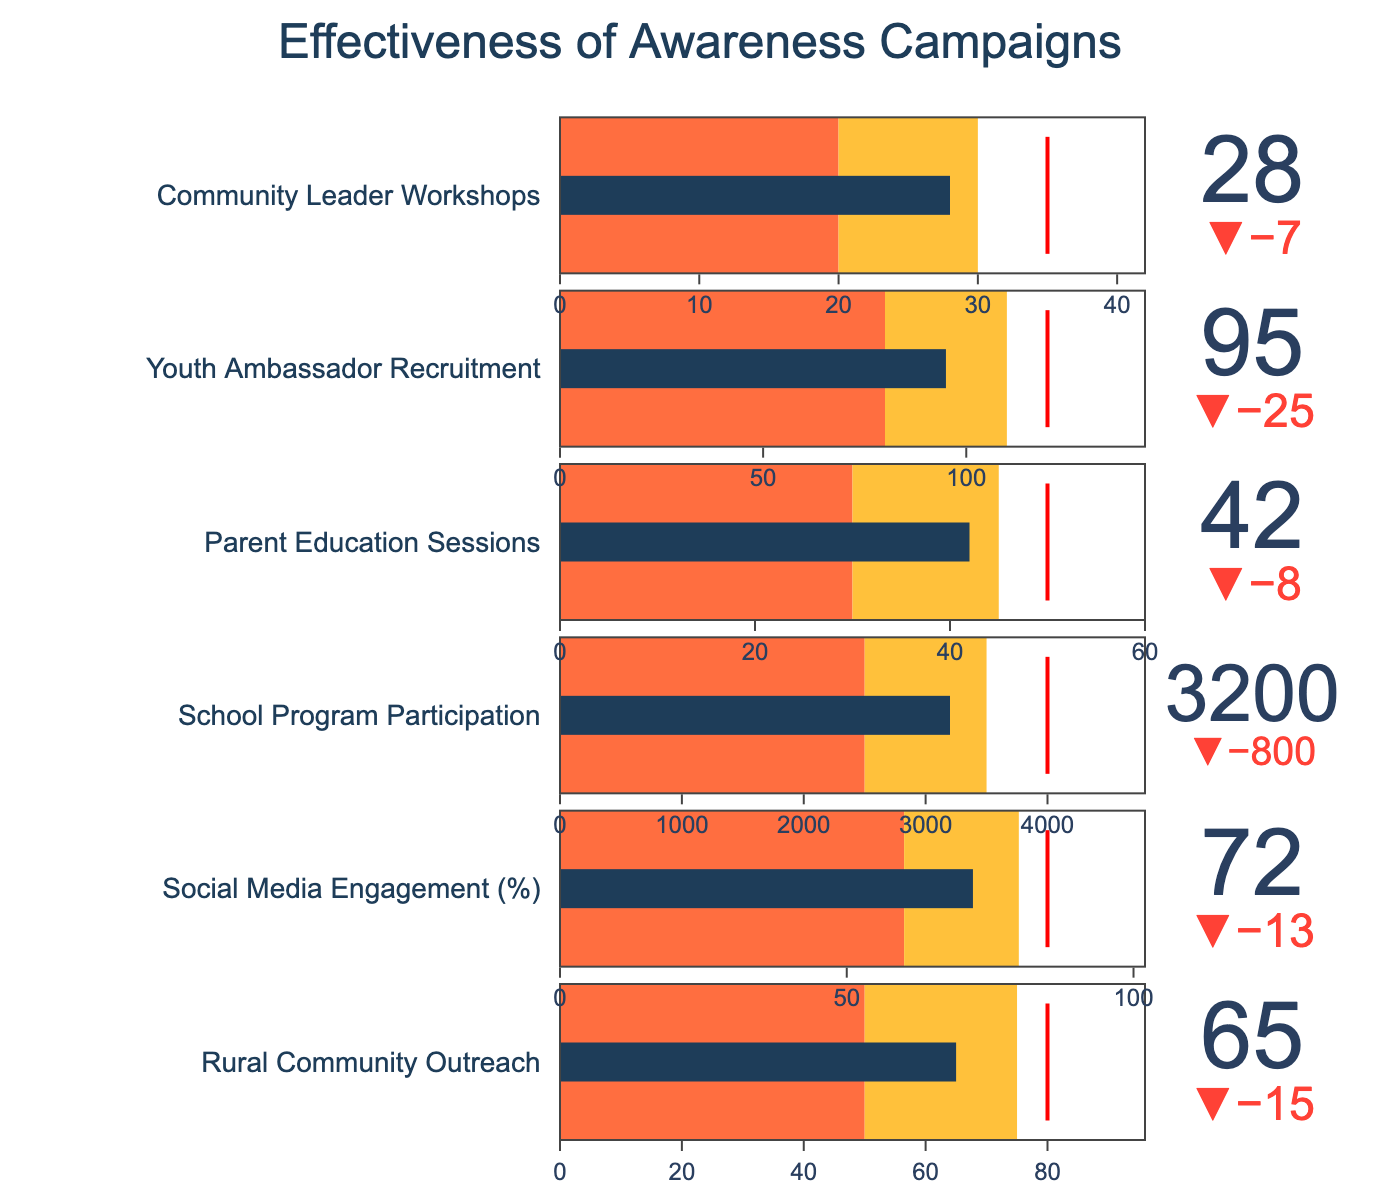What's the title of the figure? The title is located at the top center of the figure, displaying the main subject of the visualized data.
Answer: Effectiveness of Awareness Campaigns How many categories are presented in the bullet chart? By counting the number of unique titles or indicators on the left-hand side of the chart, we can determine the number of categories.
Answer: 6 Which category has the highest target value? By comparing the target values for all categories, we identify the category with the largest number.
Answer: School Program Participation For Rural Community Outreach, is the actual value above or below the satisfactory range? Assess the position of the actual value in comparison to the defined satisfactory range in the chart.
Answer: Above What's the difference between the actual and target for Social Media Engagement? Subtract the target from the actual value for the Social Media Engagement category to find the difference.
Answer: -13 How close is the actual value for Parent Education Sessions to its good range? Determine the difference between the actual value and the starting value of the good range for Parent Education Sessions.
Answer: 3 Which category shows the smallest delta value from its target? Compare the delta values (the difference between actual and target) for all categories to identify the smallest one.
Answer: Parent Education Sessions In the Community Leader Workshops category, how many steps are there within the satisfactory range? Identify the number of steps or segments that fall within the satisfactory range defined in the chart.
Answer: 1 Among all categories, which one is closest to reaching its target? Evaluate the delta values for each category to determine which has the smallest absolute difference from the target.
Answer: Parent Education Sessions For Youth Ambassador Recruitment, how far is the actual value from the threshold? Calculate the difference between the actual value and the threshold value for Youth Ambassador Recruitment.
Answer: 25 